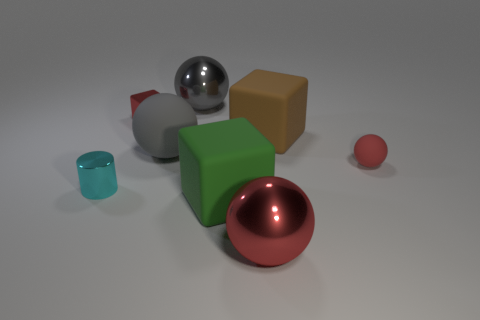Subtract all gray rubber balls. How many balls are left? 3 Subtract all green cubes. How many gray spheres are left? 2 Add 1 large purple rubber balls. How many objects exist? 9 Subtract 1 blocks. How many blocks are left? 2 Subtract all blue spheres. Subtract all brown cylinders. How many spheres are left? 4 Subtract 0 gray cylinders. How many objects are left? 8 Subtract all blocks. How many objects are left? 5 Subtract all large blue metal cylinders. Subtract all large metallic balls. How many objects are left? 6 Add 5 cyan cylinders. How many cyan cylinders are left? 6 Add 3 large brown rubber cubes. How many large brown rubber cubes exist? 4 